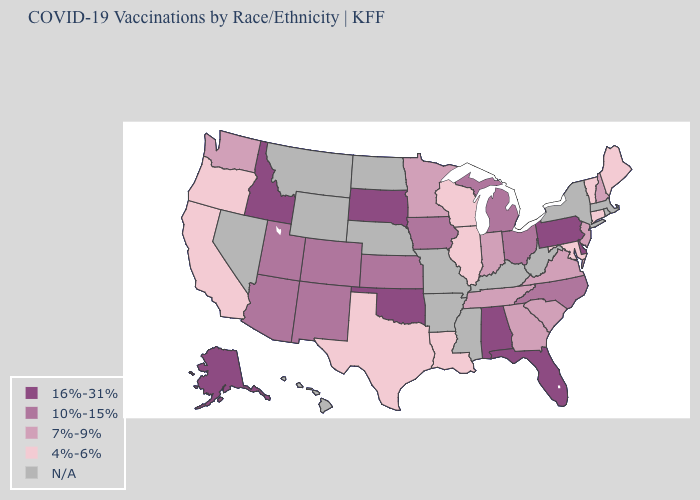What is the lowest value in the Northeast?
Quick response, please. 4%-6%. What is the value of Ohio?
Quick response, please. 10%-15%. Among the states that border Indiana , which have the lowest value?
Keep it brief. Illinois. What is the value of Nevada?
Keep it brief. N/A. How many symbols are there in the legend?
Write a very short answer. 5. Does the map have missing data?
Write a very short answer. Yes. What is the value of Utah?
Write a very short answer. 10%-15%. Name the states that have a value in the range N/A?
Answer briefly. Arkansas, Hawaii, Kentucky, Massachusetts, Mississippi, Missouri, Montana, Nebraska, Nevada, New York, North Dakota, Rhode Island, West Virginia, Wyoming. How many symbols are there in the legend?
Write a very short answer. 5. Among the states that border South Dakota , which have the highest value?
Short answer required. Iowa. Name the states that have a value in the range 10%-15%?
Short answer required. Arizona, Colorado, Iowa, Kansas, Michigan, New Mexico, North Carolina, Ohio, Utah. Among the states that border Wisconsin , does Iowa have the lowest value?
Write a very short answer. No. Which states have the highest value in the USA?
Keep it brief. Alabama, Alaska, Delaware, Florida, Idaho, Oklahoma, Pennsylvania, South Dakota. Among the states that border Delaware , which have the lowest value?
Be succinct. Maryland. Which states have the lowest value in the Northeast?
Write a very short answer. Connecticut, Maine, Vermont. 